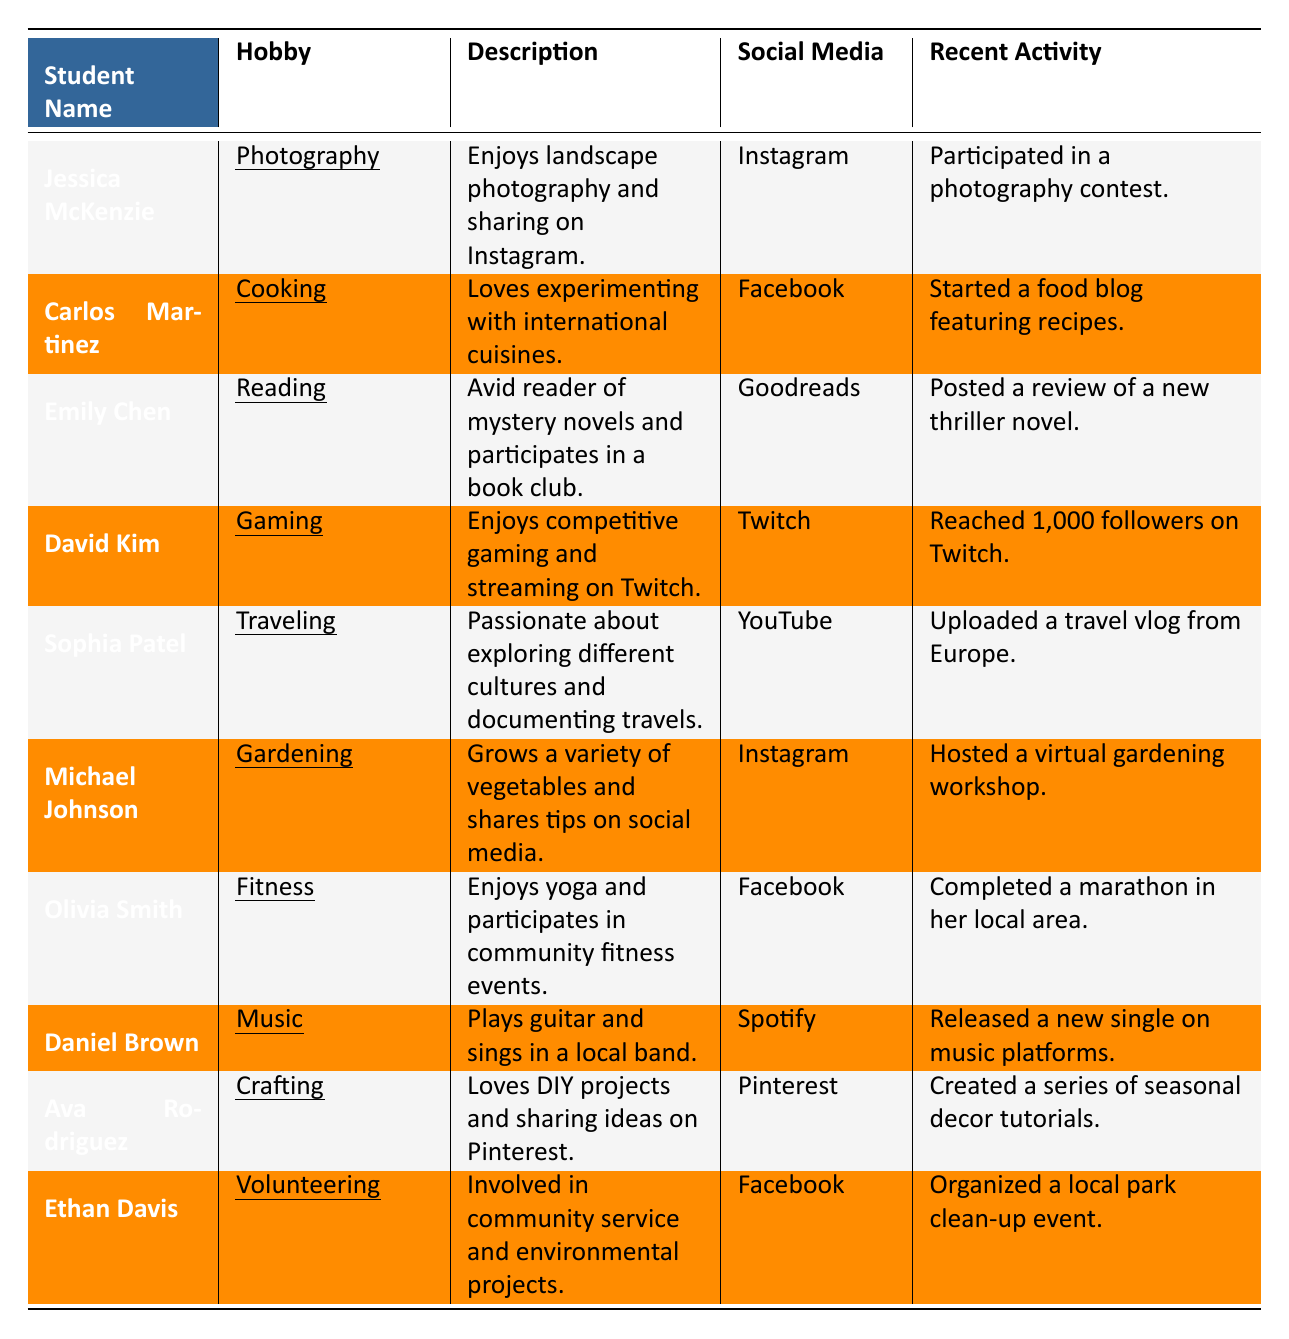What is Jessica McKenzie's hobby? The table lists Jessica McKenzie and indicates her hobby is highlighted in underlined text in the "Hobby" column
Answer: Photography Which social media platform is Carlos Martinez using? Looking in the "Social Media" column next to Carlos Martinez's name, it shows that he uses Facebook
Answer: Facebook What recent activity did Emily Chen participate in? The "Recent Activity" column next to Emily Chen says she posted a review of a new thriller novel
Answer: Posted a review of a new thriller novel How many followers did David Kim reach on Twitch? The information in the "Recent Activity" column next to David Kim indicates that he reached 1,000 followers on Twitch
Answer: 1,000 followers Is Sophia Patel passionate about cooking? Referring to the "Hobby" column for Sophia Patel, her hobby is traveling, not cooking, hence the statement is false
Answer: No Which hobby is associated with Olivia Smith? In the "Hobby" column next to Olivia Smith’s name, it states her hobby is fitness
Answer: Fitness What are the recent activities of Michael Johnson regarding gardening? The "Recent Activity" column shows Michael Johnson hosted a virtual gardening workshop, reflecting his engagement with gardening
Answer: Hosted a virtual gardening workshop Which student is involved in environmental projects? Looking under the "Hobby" column, the table shows Ethan Davis is involved in volunteering, reflecting involvement in environmental projects
Answer: Ethan Davis How many students have cooking or crafting as their hobbies? Carlos Martinez has cooking, and Ava Rodriguez has crafting, totaling to 2 students
Answer: 2 What type of books does Emily Chen read? The "Description" column indicates Emily Chen is an avid reader of mystery novels, specifying the type of books she enjoys
Answer: Mystery novels 